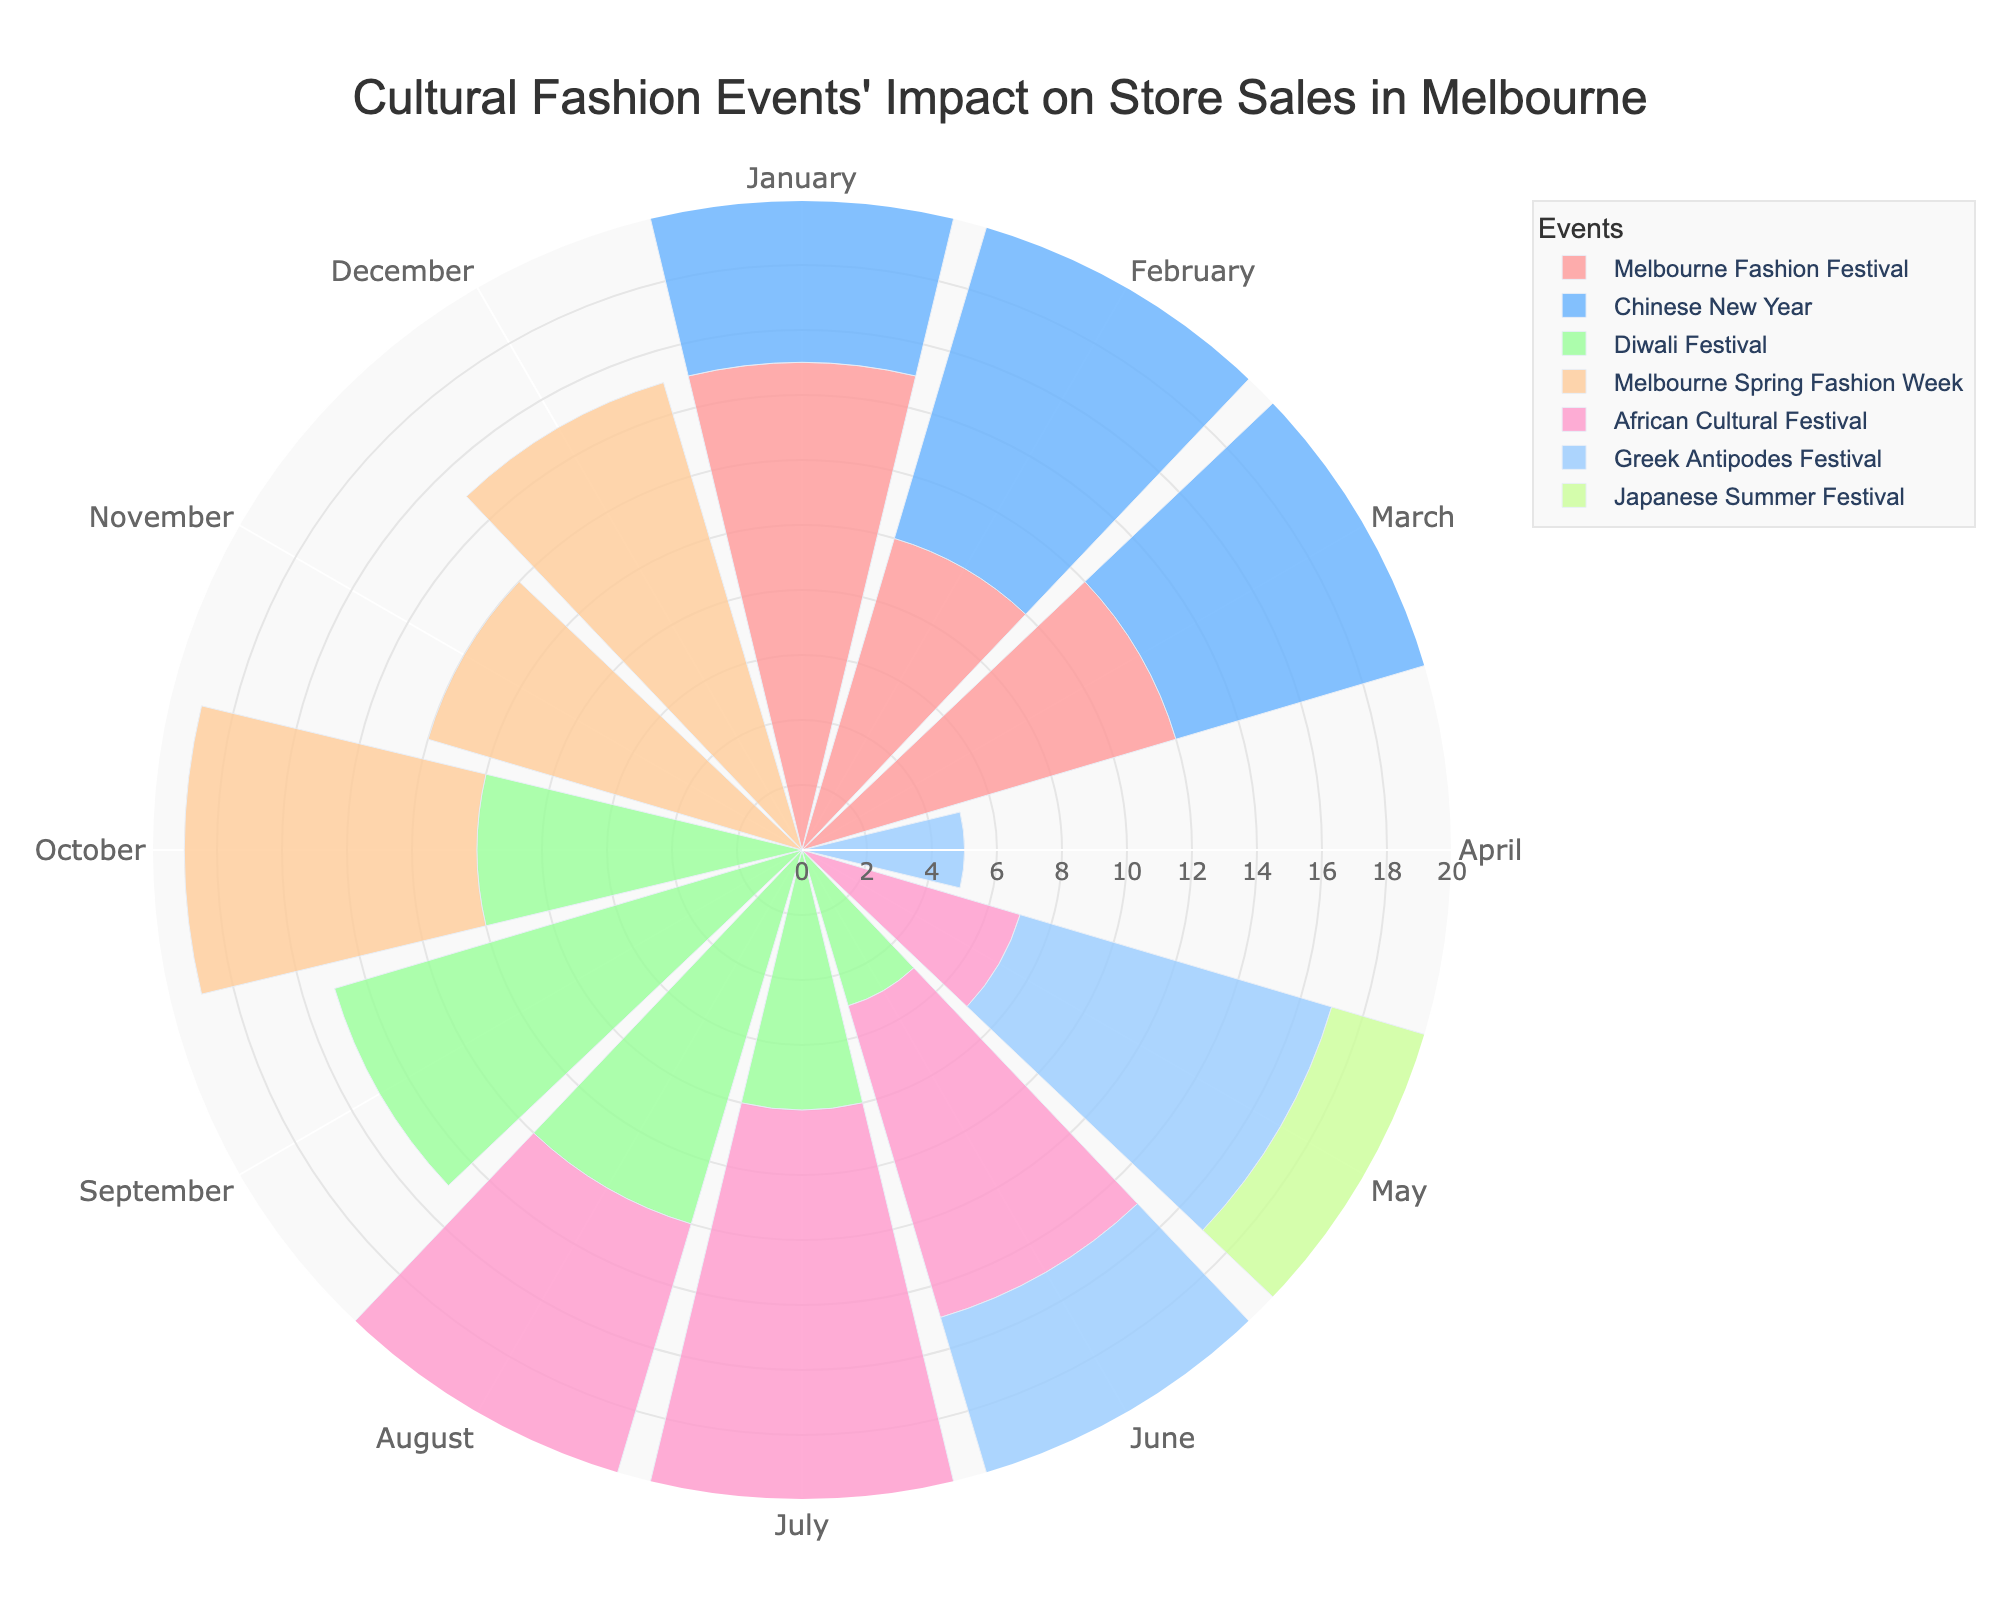What is the title of the chart? The title is located at the top of the chart, typically in larger font size and darker color compared to the other text. It provides a summary of what the entire chart is about.
Answer: "Cultural Fashion Events' Impact on Store Sales in Melbourne" How many events are represented in the chart? Count the number of different event names listed in the legend or plotted in different colors on the chart.
Answer: 7 Which event has the highest impact in March? Look for the bar segment in the month of March with the highest radial value and identify the event it corresponds to.
Answer: Chinese New Year In which month does the Greek Antipodes Festival have the highest impact? Find the bars corresponding to the Greek Antipodes Festival and note the highest value among the months.
Answer: June Compare the impact of the Melbourne Spring Fashion Week in October and December. Which month has a higher impact? Look at the bars for Melbourne Spring Fashion Week in October and December, respectively, and compare their heights.
Answer: December What is the combined impact of the African Cultural Festival in May and June? Find the values for the African Cultural Festival in May and June, and add them together. May: 7, June: 10
Answer: 17 During which months does the Japanese Summer Festival have an impact on store sales? Identify the months where the radial value is greater than zero for the Japanese Summer Festival.
Answer: June, July, August Which event dominates the store sales impact in September? Look for the event with the highest radial value in the month of September in the polar chart.
Answer: Diwali Festival What is the average impact of the Melbourne Fashion Festival over its active months? Sum the impacts of the Melbourne Fashion Festival and divide by the number of active months. Values: 15, 10, 12 (January, February, March). Sum is 37, active months are 3.
Answer: 12.33 Is there any month where no event impacts store sales at all? If so, which month(s)? Check each month to see if there are any months with no bars (impacts of zero) across all events.
Answer: Not Applicable 